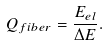Convert formula to latex. <formula><loc_0><loc_0><loc_500><loc_500>Q _ { f i b e r } = \frac { E _ { e l } } { \Delta E } .</formula> 